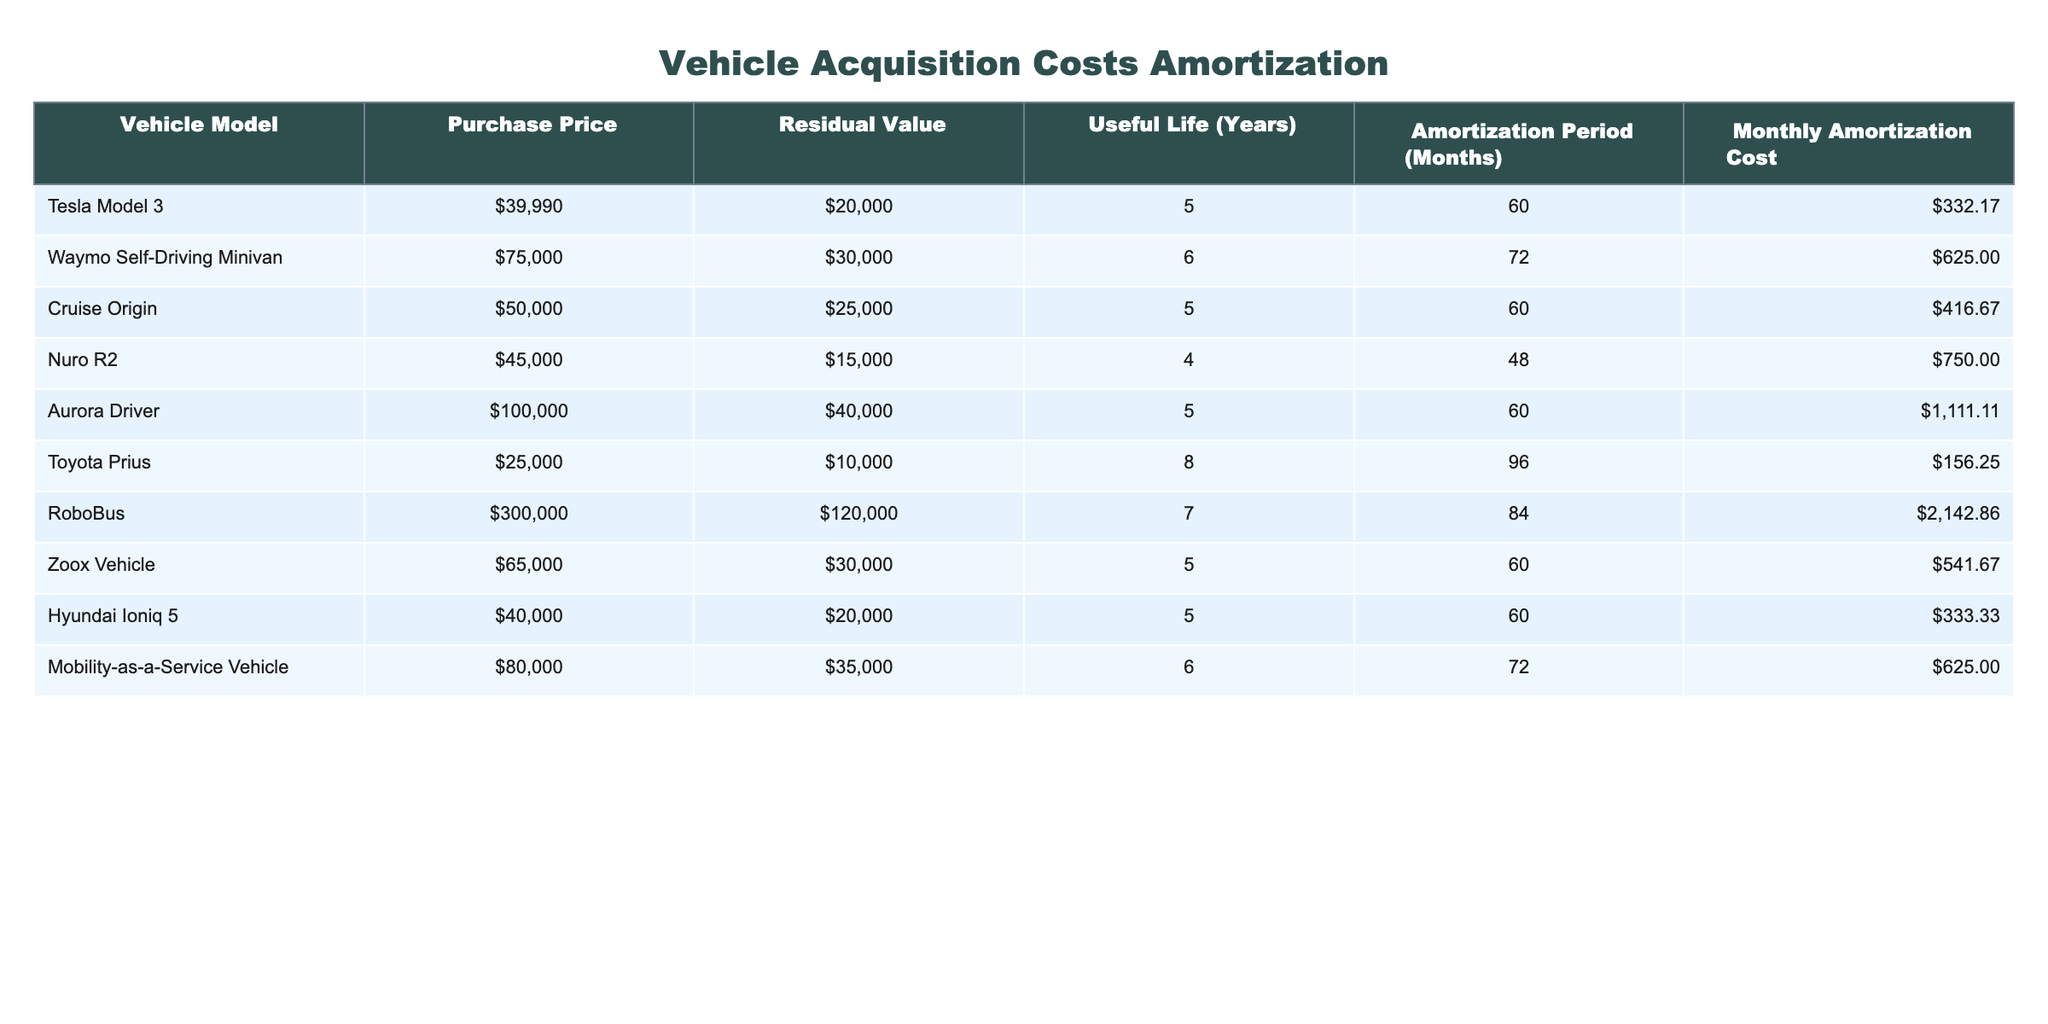What is the purchase price of the Waymo Self-Driving Minivan? The table lists the purchase price of the Waymo Self-Driving Minivan in the corresponding row under the 'Purchase Price' column, which is 75000.
Answer: 75000 What is the residual value of the Nuro R2? To find the residual value, look for the Nuro R2 entry in the table's 'Residual Value' column, which shows 15000.
Answer: 15000 How many vehicles have a monthly amortization cost of more than 500? By inspecting the 'Monthly Amortization Cost' column, I count the vehicles priced above 500: the Waymo Self-Driving Minivan, Nuro R2, Aurora Driver, RoboBus, and Mobility-as-a-Service Vehicle, making a total of 5 vehicles.
Answer: 5 What is the total purchase price of all vehicles combined? To find the total purchase price, sum the values in the 'Purchase Price' column: 39990 + 75000 + 50000 + 45000 + 100000 + 25000 + 300000 + 65000 + 40000 + 80000 =  610000.
Answer: 610000 Is the Toyota Prius's useful life greater than or equal to 6 years? The table shows that the useful life of the Toyota Prius is 8 years, which is greater than 6 years, so the answer is yes.
Answer: Yes Which vehicle has the longest amortization period? In the table, I check the 'Amortization Period (Months)' column for the maximum value, where the RoboBus has an amortization period of 84 months, making it the longest.
Answer: RoboBus What is the average monthly amortization cost of all vehicles? To find the average, sum all values in the 'Monthly Amortization Cost' (332.17 + 625.00 + 416.67 + 750.00 + 1111.11 + 156.25 + 2142.86 + 541.67 + 333.33 + 625.00 =  6590.00), then divide by the total number of vehicles (10), yielding an average of 6590.00 / 10 = 659.00.
Answer: 659.00 Are any vehicles listed with a purchase price below 30,000? By examining the 'Purchase Price' column for the minimum value, we find the Toyota Prius listed at 25000, which confirms that yes, there is at least one vehicle listed below 30,000.
Answer: Yes What is the difference in the monthly amortization cost between the most expensive and the least expensive vehicle? The most expensive monthly amortization cost is for RoboBus at 2142.86 and the least is for Tesla Model 3 at 332.17. The difference is 2142.86 - 332.17 = 1810.69.
Answer: 1810.69 